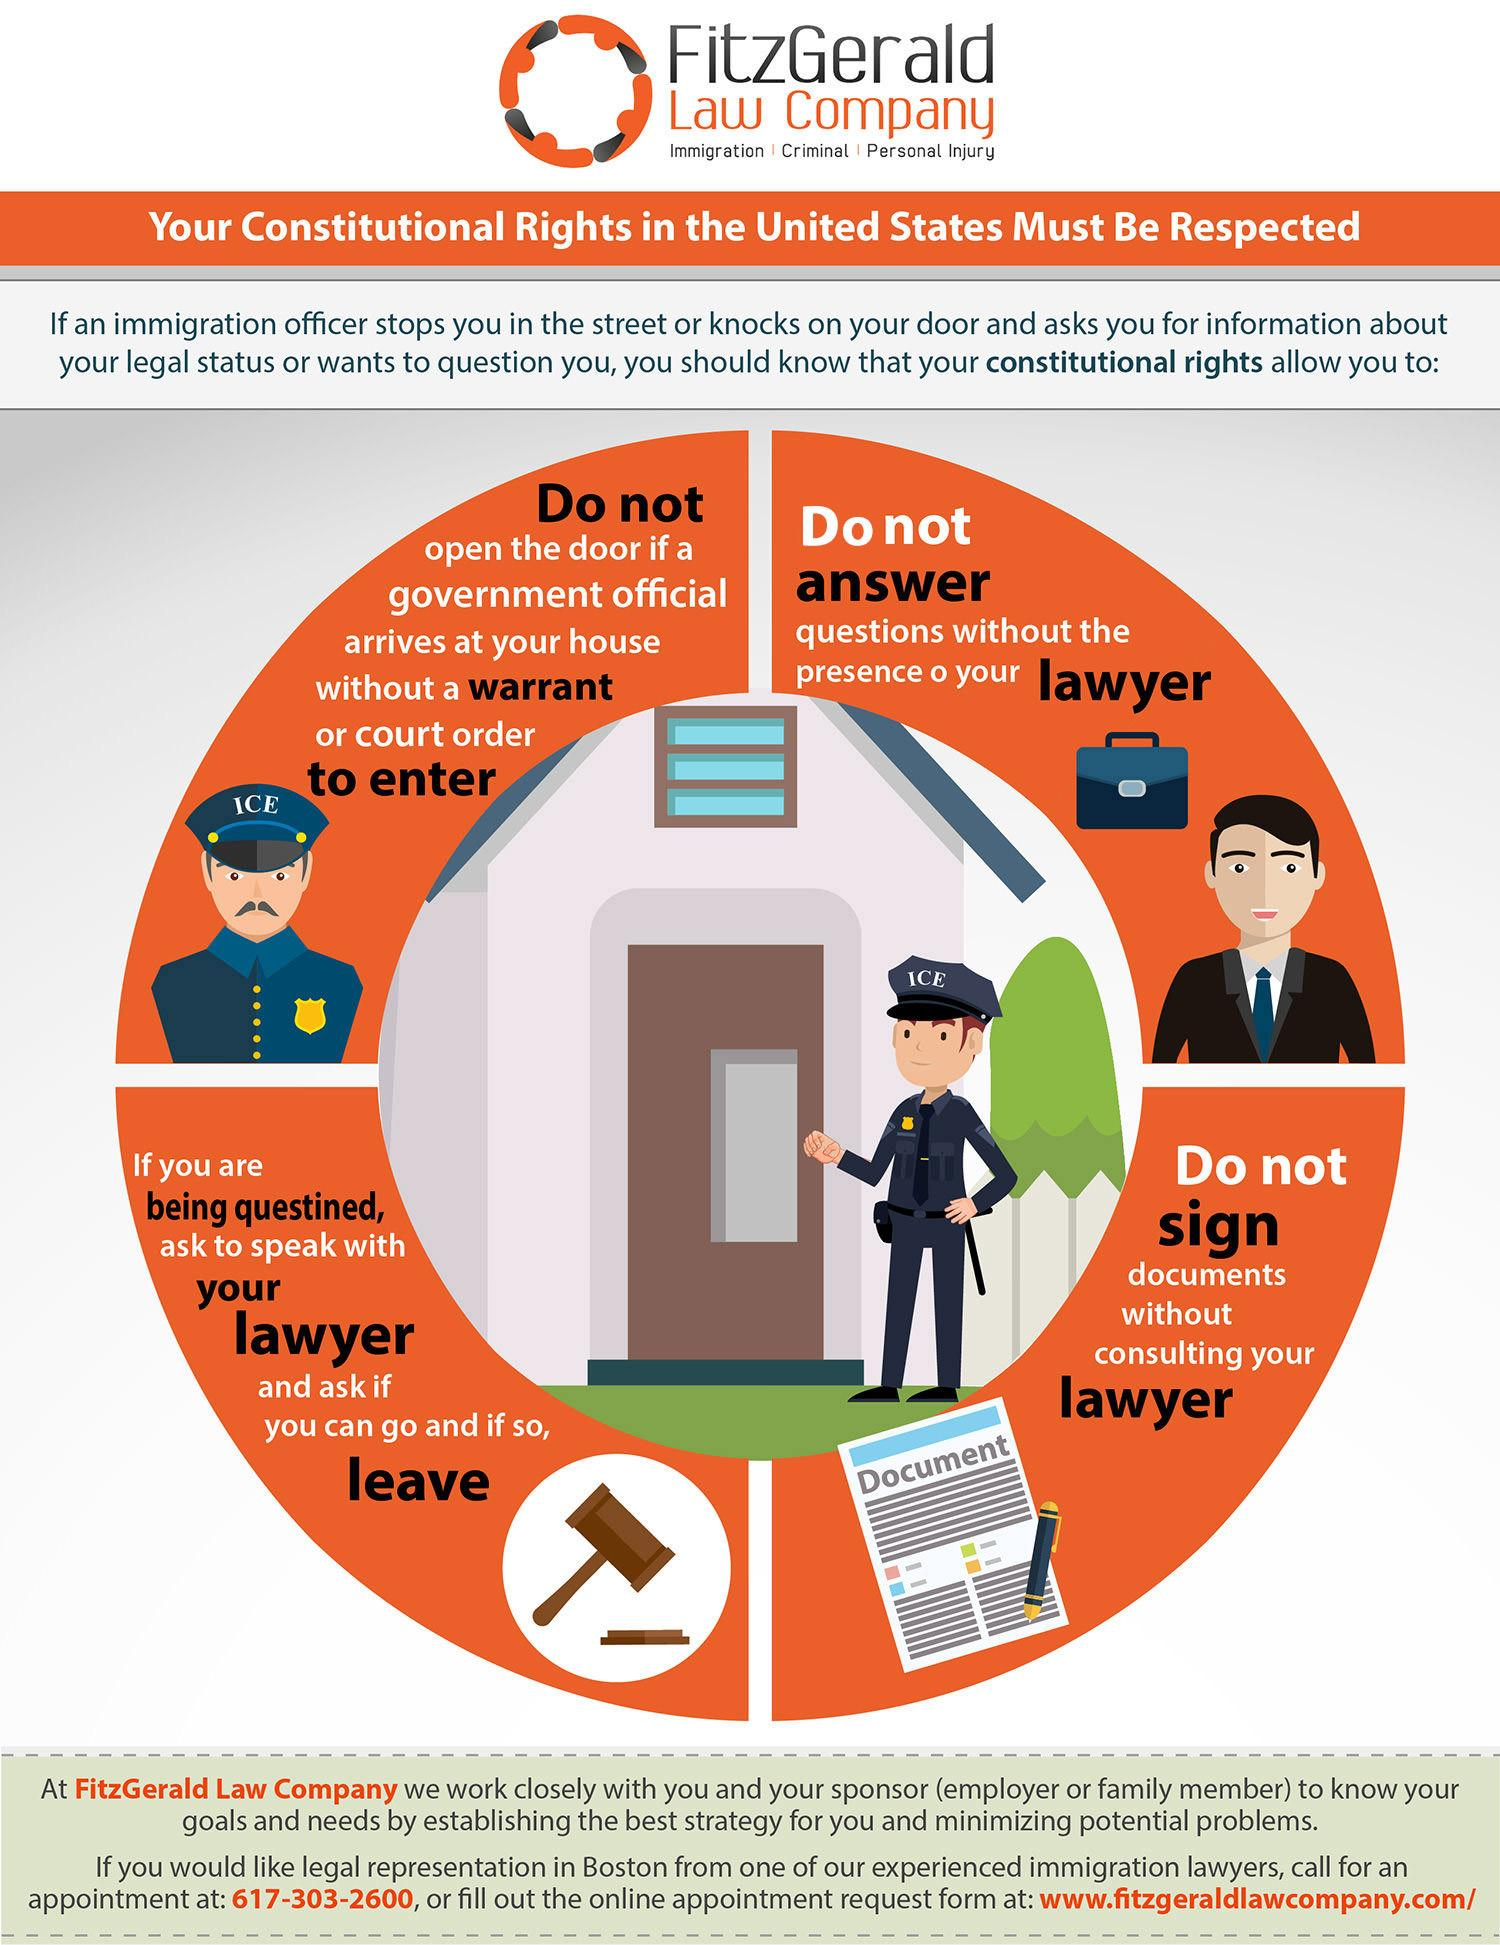Mention a couple of crucial points in this snapshot. The cap of the policeman is written with the word 'ICE,'" declares the sentence. The individual has the right to exercise four constitutional rights while being questioned by an immigration officer. 